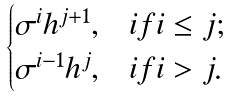<formula> <loc_0><loc_0><loc_500><loc_500>\begin{cases} \sigma ^ { i } h ^ { j + 1 } , & i f i \leq j ; \\ \sigma ^ { i - 1 } h ^ { j } , & i f i > j . \end{cases}</formula> 